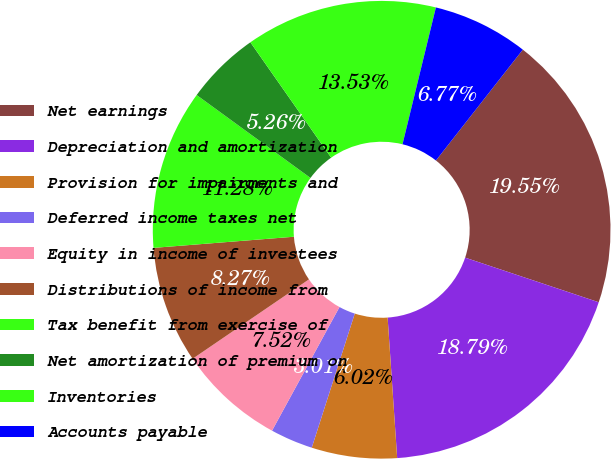<chart> <loc_0><loc_0><loc_500><loc_500><pie_chart><fcel>Net earnings<fcel>Depreciation and amortization<fcel>Provision for impairments and<fcel>Deferred income taxes net<fcel>Equity in income of investees<fcel>Distributions of income from<fcel>Tax benefit from exercise of<fcel>Net amortization of premium on<fcel>Inventories<fcel>Accounts payable<nl><fcel>19.55%<fcel>18.79%<fcel>6.02%<fcel>3.01%<fcel>7.52%<fcel>8.27%<fcel>11.28%<fcel>5.26%<fcel>13.53%<fcel>6.77%<nl></chart> 